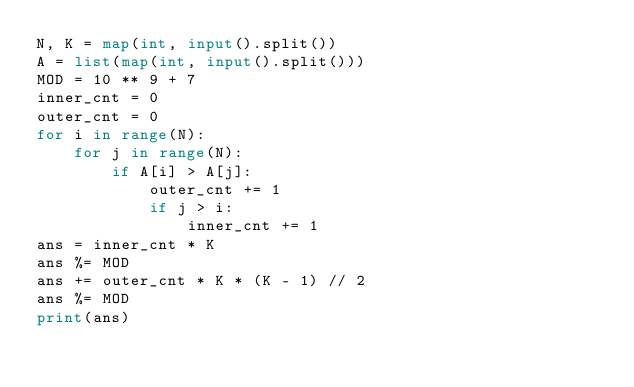Convert code to text. <code><loc_0><loc_0><loc_500><loc_500><_Python_>N, K = map(int, input().split())
A = list(map(int, input().split()))
MOD = 10 ** 9 + 7
inner_cnt = 0
outer_cnt = 0
for i in range(N):
    for j in range(N):
        if A[i] > A[j]:
            outer_cnt += 1
            if j > i:
                inner_cnt += 1
ans = inner_cnt * K
ans %= MOD
ans += outer_cnt * K * (K - 1) // 2
ans %= MOD
print(ans)
</code> 